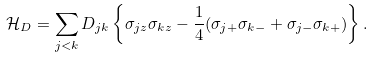Convert formula to latex. <formula><loc_0><loc_0><loc_500><loc_500>\mathcal { H } _ { D } = \sum _ { j < k } D _ { j k } \left \{ \sigma _ { j z } \sigma _ { k z } - \frac { 1 } { 4 } ( \sigma _ { j + } \sigma _ { k - } + \sigma _ { j - } \sigma _ { k + } ) \right \} .</formula> 